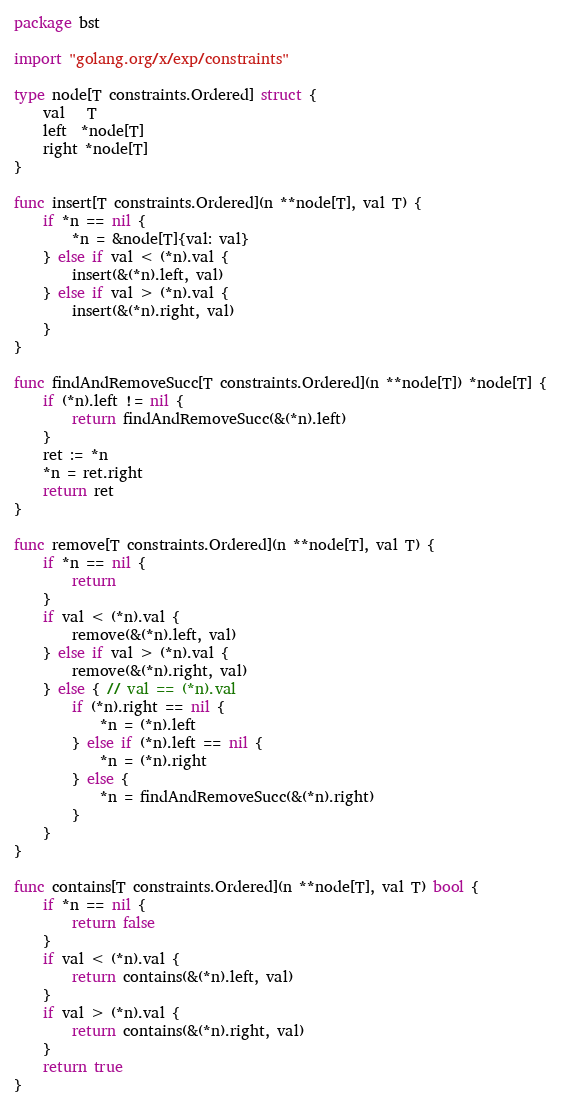<code> <loc_0><loc_0><loc_500><loc_500><_Go_>package bst

import "golang.org/x/exp/constraints"

type node[T constraints.Ordered] struct {
	val   T
	left  *node[T]
	right *node[T]
}

func insert[T constraints.Ordered](n **node[T], val T) {
	if *n == nil {
		*n = &node[T]{val: val}
	} else if val < (*n).val {
		insert(&(*n).left, val)
	} else if val > (*n).val {
		insert(&(*n).right, val)
	}
}

func findAndRemoveSucc[T constraints.Ordered](n **node[T]) *node[T] {
	if (*n).left != nil {
		return findAndRemoveSucc(&(*n).left)
	}
	ret := *n
	*n = ret.right
	return ret
}

func remove[T constraints.Ordered](n **node[T], val T) {
	if *n == nil {
		return
	}
	if val < (*n).val {
		remove(&(*n).left, val)
	} else if val > (*n).val {
		remove(&(*n).right, val)
	} else { // val == (*n).val
		if (*n).right == nil {
			*n = (*n).left
		} else if (*n).left == nil {
			*n = (*n).right
		} else {
			*n = findAndRemoveSucc(&(*n).right)
		}
	}
}

func contains[T constraints.Ordered](n **node[T], val T) bool {
	if *n == nil {
		return false
	}
	if val < (*n).val {
		return contains(&(*n).left, val)
	}
	if val > (*n).val {
		return contains(&(*n).right, val)
	}
	return true
}
</code> 